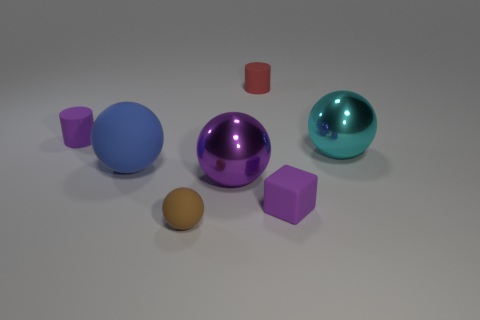How many tiny red rubber blocks are there?
Provide a short and direct response. 0. The tiny object that is in front of the purple metal ball and to the right of the small brown thing has what shape?
Ensure brevity in your answer.  Cube. Do the shiny thing right of the tiny purple block and the large sphere that is to the left of the purple shiny sphere have the same color?
Make the answer very short. No. There is a metal ball that is the same color as the small block; what is its size?
Ensure brevity in your answer.  Large. Is there a purple cylinder made of the same material as the brown ball?
Offer a very short reply. Yes. Is the number of small purple objects left of the purple shiny ball the same as the number of tiny things behind the tiny brown object?
Your answer should be compact. No. What is the size of the purple rubber object in front of the purple ball?
Your answer should be very brief. Small. There is a small thing that is behind the tiny matte thing left of the tiny brown ball; what is it made of?
Provide a short and direct response. Rubber. How many big rubber spheres are in front of the small cylinder that is on the left side of the cylinder on the right side of the purple sphere?
Your answer should be very brief. 1. Do the small cube in front of the large blue thing and the tiny purple thing that is behind the tiny purple rubber cube have the same material?
Ensure brevity in your answer.  Yes. 